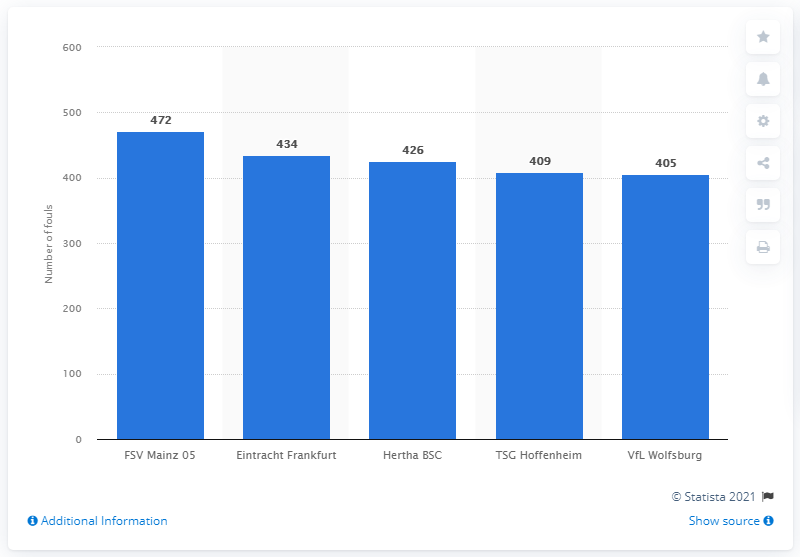Specify some key components in this picture. FSV Mainz 05 committed 472 fouls. 